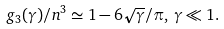<formula> <loc_0><loc_0><loc_500><loc_500>g _ { 3 } ( \gamma ) / n ^ { 3 } \simeq 1 - 6 \sqrt { \gamma } / \pi , \, \gamma \ll 1 .</formula> 